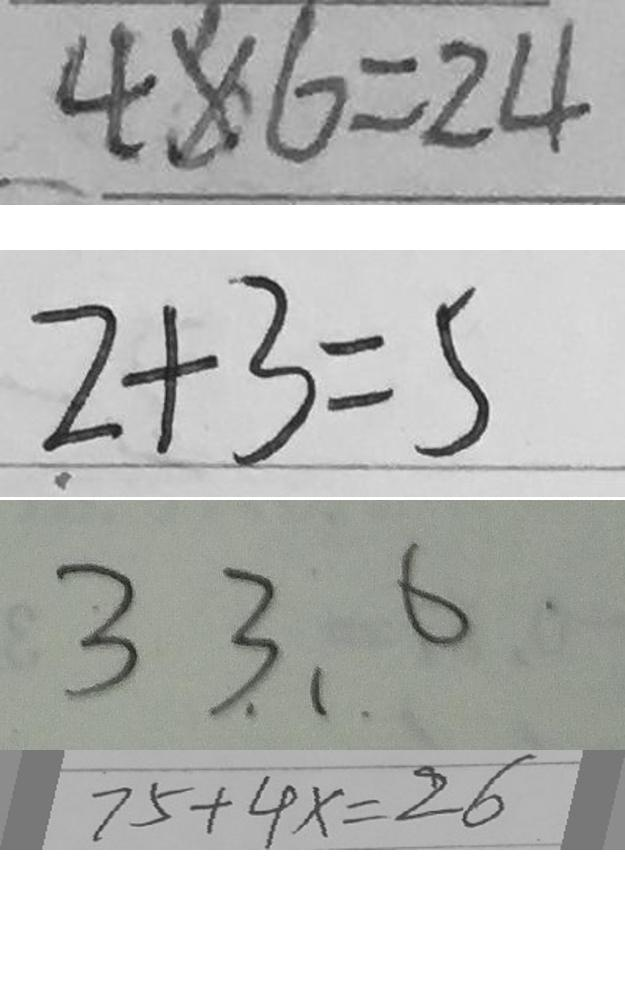<formula> <loc_0><loc_0><loc_500><loc_500>4 \times 6 = 2 4 
 2 + 3 = 5 
 3 3 . 、 . 6 
 7 5 + 4 x = 2 6</formula> 